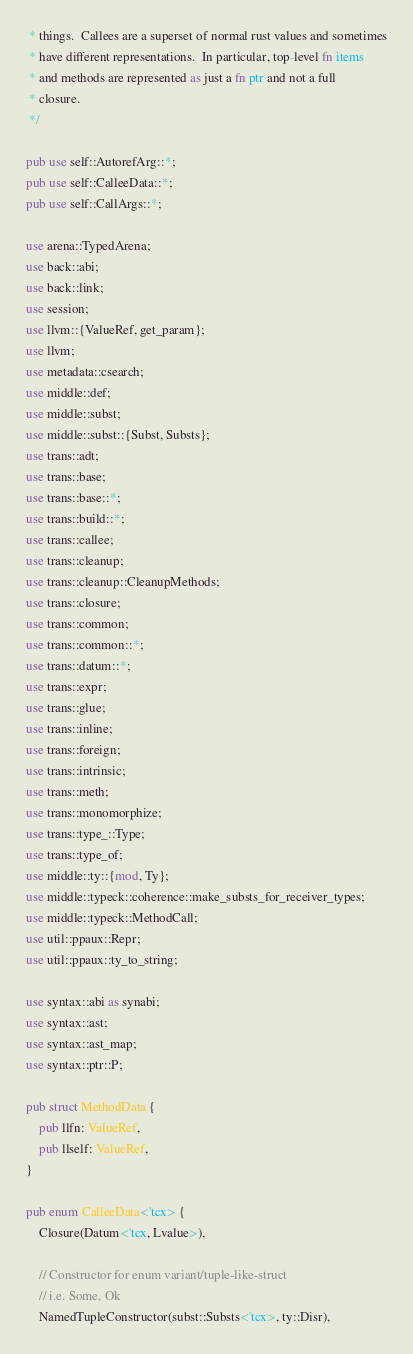<code> <loc_0><loc_0><loc_500><loc_500><_Rust_> * things.  Callees are a superset of normal rust values and sometimes
 * have different representations.  In particular, top-level fn items
 * and methods are represented as just a fn ptr and not a full
 * closure.
 */

pub use self::AutorefArg::*;
pub use self::CalleeData::*;
pub use self::CallArgs::*;

use arena::TypedArena;
use back::abi;
use back::link;
use session;
use llvm::{ValueRef, get_param};
use llvm;
use metadata::csearch;
use middle::def;
use middle::subst;
use middle::subst::{Subst, Substs};
use trans::adt;
use trans::base;
use trans::base::*;
use trans::build::*;
use trans::callee;
use trans::cleanup;
use trans::cleanup::CleanupMethods;
use trans::closure;
use trans::common;
use trans::common::*;
use trans::datum::*;
use trans::expr;
use trans::glue;
use trans::inline;
use trans::foreign;
use trans::intrinsic;
use trans::meth;
use trans::monomorphize;
use trans::type_::Type;
use trans::type_of;
use middle::ty::{mod, Ty};
use middle::typeck::coherence::make_substs_for_receiver_types;
use middle::typeck::MethodCall;
use util::ppaux::Repr;
use util::ppaux::ty_to_string;

use syntax::abi as synabi;
use syntax::ast;
use syntax::ast_map;
use syntax::ptr::P;

pub struct MethodData {
    pub llfn: ValueRef,
    pub llself: ValueRef,
}

pub enum CalleeData<'tcx> {
    Closure(Datum<'tcx, Lvalue>),

    // Constructor for enum variant/tuple-like-struct
    // i.e. Some, Ok
    NamedTupleConstructor(subst::Substs<'tcx>, ty::Disr),
</code> 